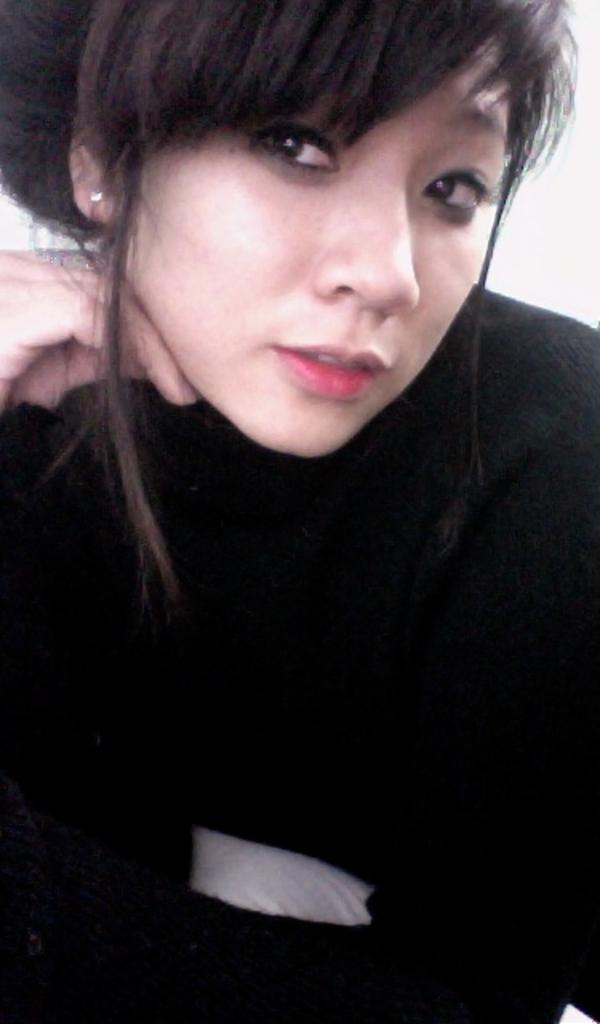What is the main subject of the image? The main subject of the image is a woman. What is the woman wearing in the image? The woman is wearing a black T-shirt in the image. How many sheep can be seen in the image? There are no sheep present in the image. What type of crime is being committed in the image? There is no crime being committed in the image; it features a woman wearing a black T-shirt. 